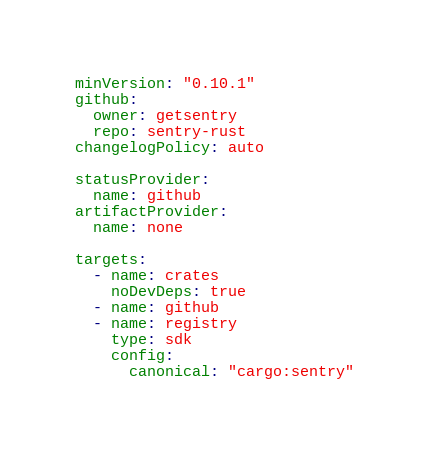<code> <loc_0><loc_0><loc_500><loc_500><_YAML_>minVersion: "0.10.1"
github:
  owner: getsentry
  repo: sentry-rust
changelogPolicy: auto

statusProvider:
  name: github
artifactProvider:
  name: none

targets:
  - name: crates
    noDevDeps: true
  - name: github
  - name: registry
    type: sdk
    config:
      canonical: "cargo:sentry"
</code> 